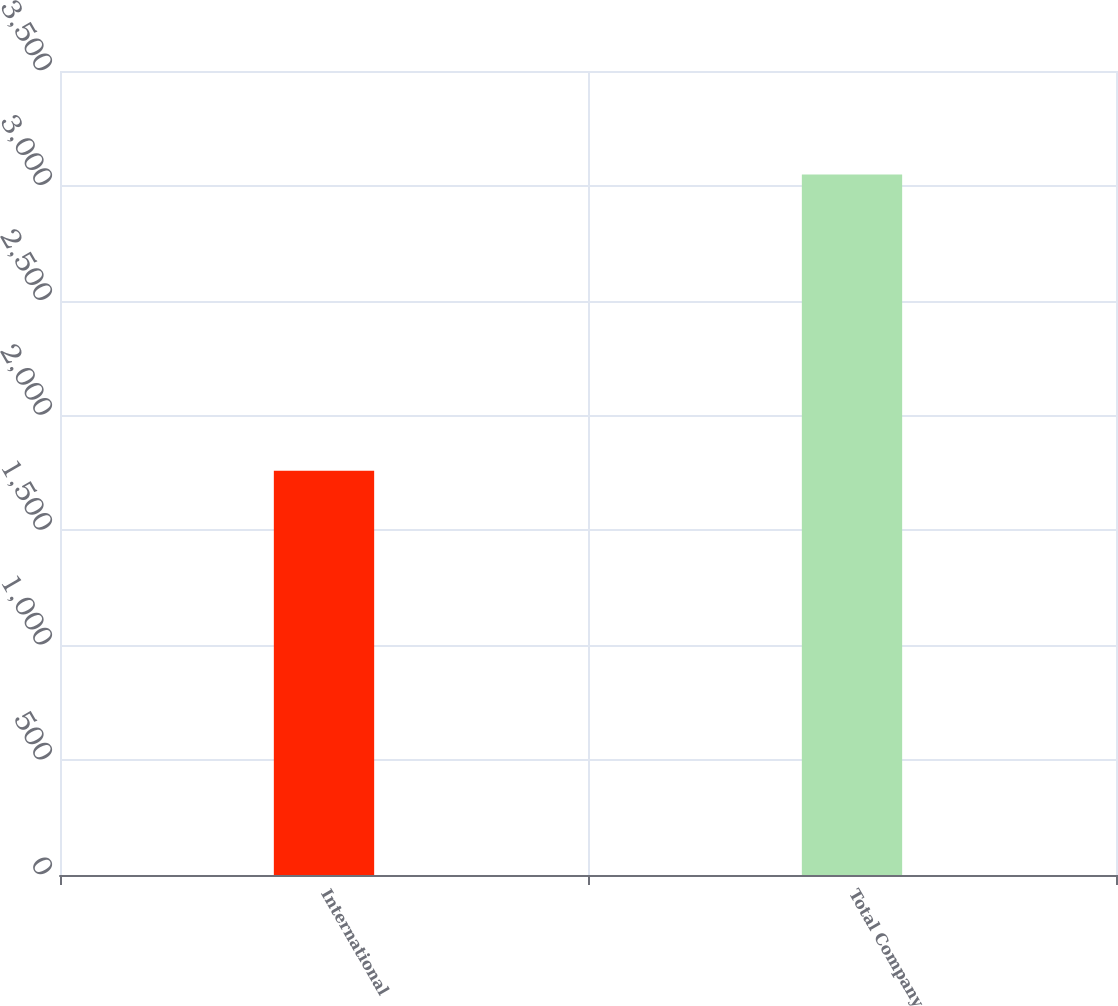<chart> <loc_0><loc_0><loc_500><loc_500><bar_chart><fcel>International<fcel>Total Company<nl><fcel>1759.7<fcel>3049.8<nl></chart> 